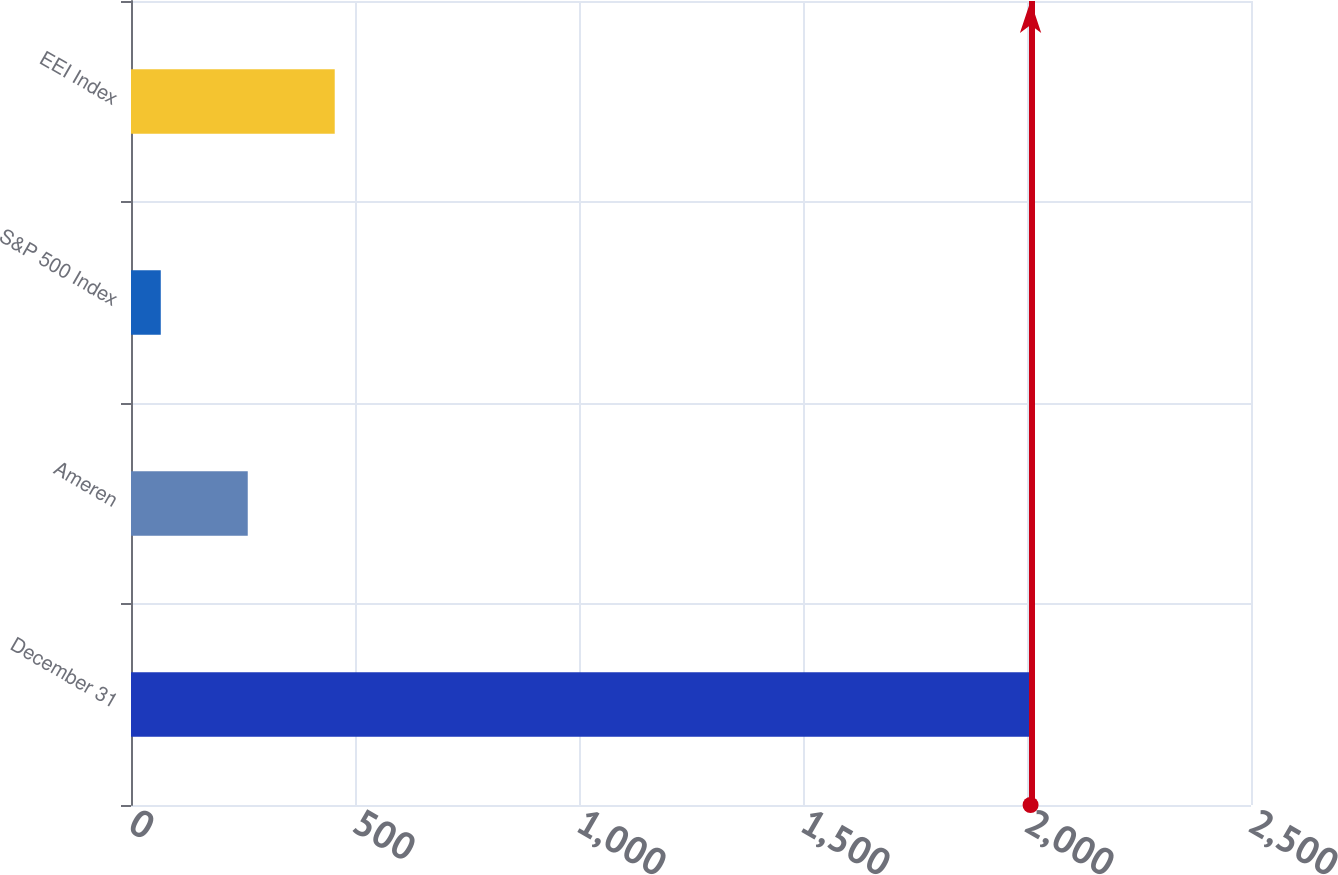<chart> <loc_0><loc_0><loc_500><loc_500><bar_chart><fcel>December 31<fcel>Ameren<fcel>S&P 500 Index<fcel>EEI Index<nl><fcel>2008<fcel>260.61<fcel>66.46<fcel>454.76<nl></chart> 